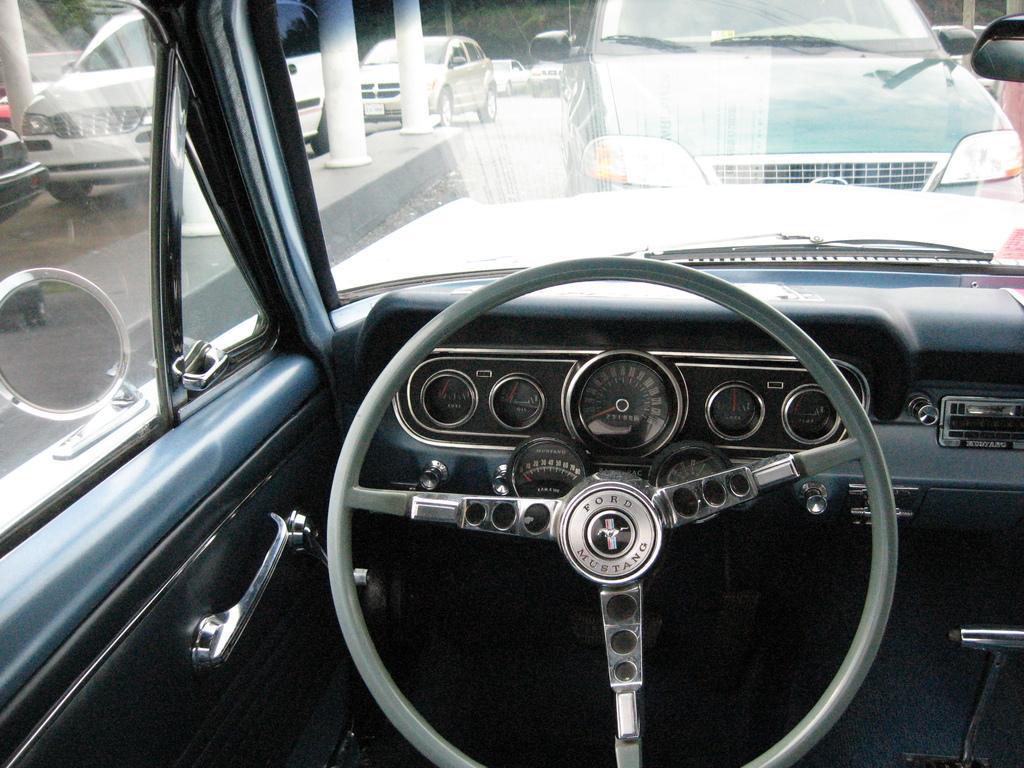How would you summarize this image in a sentence or two? In this picture there is a interior of a car which has a steering and some other objects beside it and there are few other cars in front of it and there are trees in the background. 